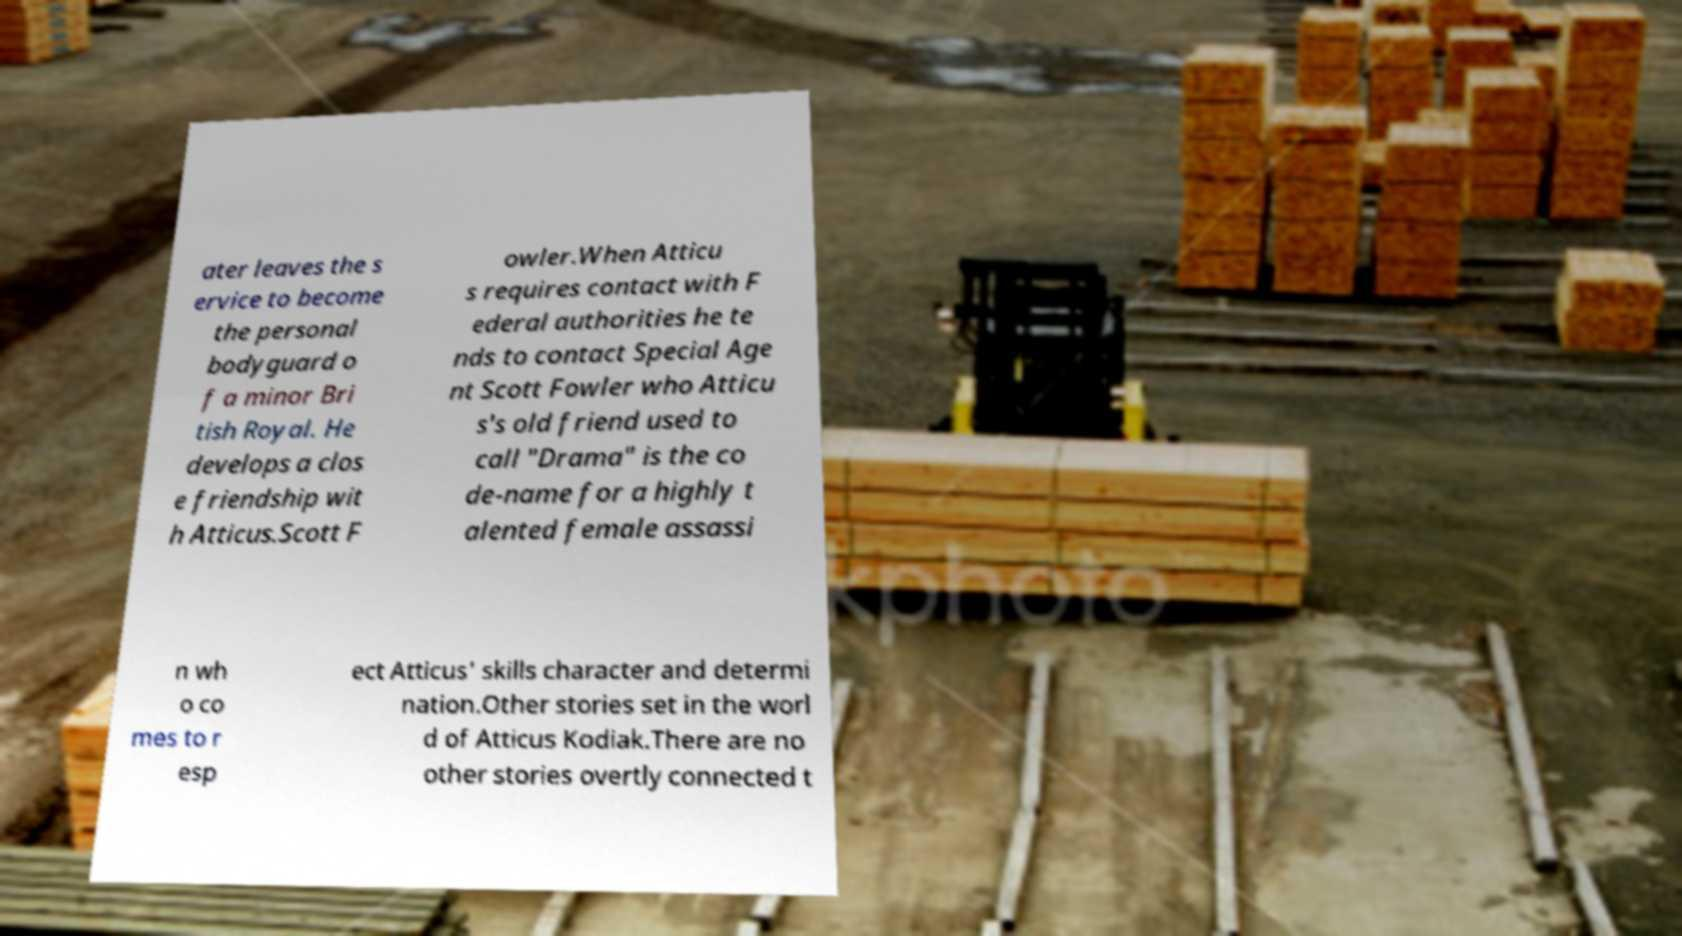Can you read and provide the text displayed in the image?This photo seems to have some interesting text. Can you extract and type it out for me? ater leaves the s ervice to become the personal bodyguard o f a minor Bri tish Royal. He develops a clos e friendship wit h Atticus.Scott F owler.When Atticu s requires contact with F ederal authorities he te nds to contact Special Age nt Scott Fowler who Atticu s's old friend used to call "Drama" is the co de-name for a highly t alented female assassi n wh o co mes to r esp ect Atticus' skills character and determi nation.Other stories set in the worl d of Atticus Kodiak.There are no other stories overtly connected t 